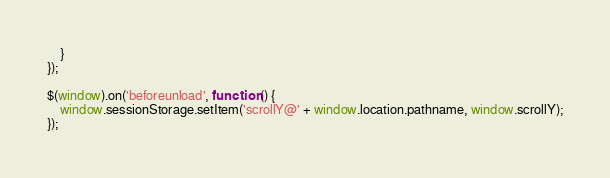<code> <loc_0><loc_0><loc_500><loc_500><_JavaScript_>    }
});

$(window).on('beforeunload', function () {
    window.sessionStorage.setItem('scrollY@' + window.location.pathname, window.scrollY);
});
</code> 